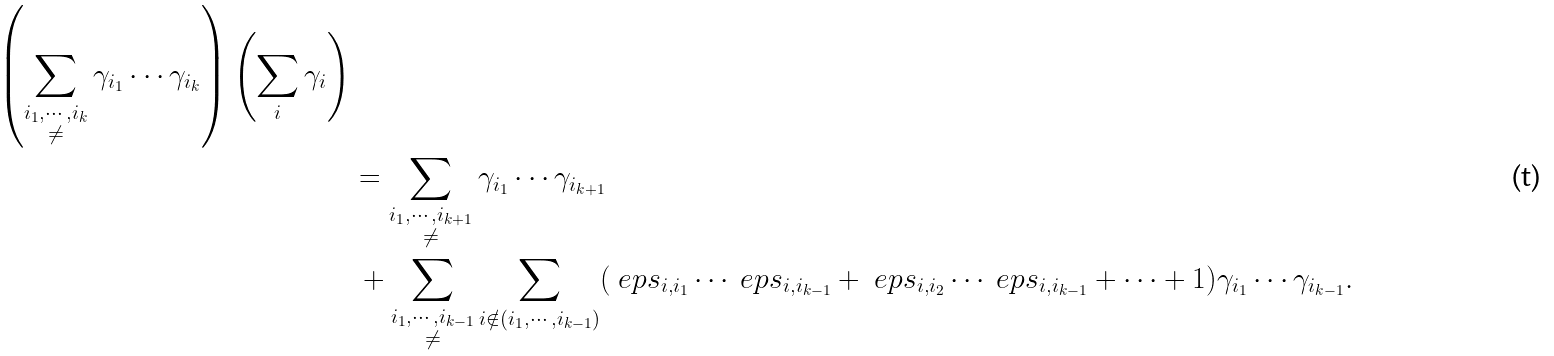<formula> <loc_0><loc_0><loc_500><loc_500>{ \left ( \sum _ { \substack { i _ { 1 } , \cdots , i _ { k } \\ \ne } } \gamma _ { i _ { 1 } } \cdots \gamma _ { i _ { k } } \right ) \left ( \sum _ { i } \gamma _ { i } \right ) } \\ & = \sum _ { \substack { i _ { 1 } , \cdots , i _ { k + 1 } \\ \ne } } \gamma _ { i _ { 1 } } \cdots \gamma _ { i _ { k + 1 } } \\ & \, + \sum _ { \substack { i _ { 1 } , \cdots , i _ { k - 1 } \\ \ne } } \sum _ { i \notin ( i _ { 1 } , \cdots , i _ { k - 1 } ) } ( \ e p s _ { i , i _ { 1 } } \cdots \ e p s _ { i , i _ { k - 1 } } + \ e p s _ { i , i _ { 2 } } \cdots \ e p s _ { i , i _ { k - 1 } } + \cdots + 1 ) \gamma _ { i _ { 1 } } \cdots \gamma _ { i _ { k - 1 } } .</formula> 